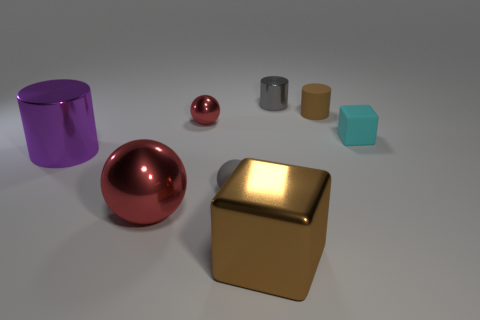Add 1 green cylinders. How many objects exist? 9 Subtract all cylinders. How many objects are left? 5 Subtract all brown shiny objects. Subtract all small matte cubes. How many objects are left? 6 Add 8 brown cylinders. How many brown cylinders are left? 9 Add 5 tiny rubber balls. How many tiny rubber balls exist? 6 Subtract 0 green spheres. How many objects are left? 8 